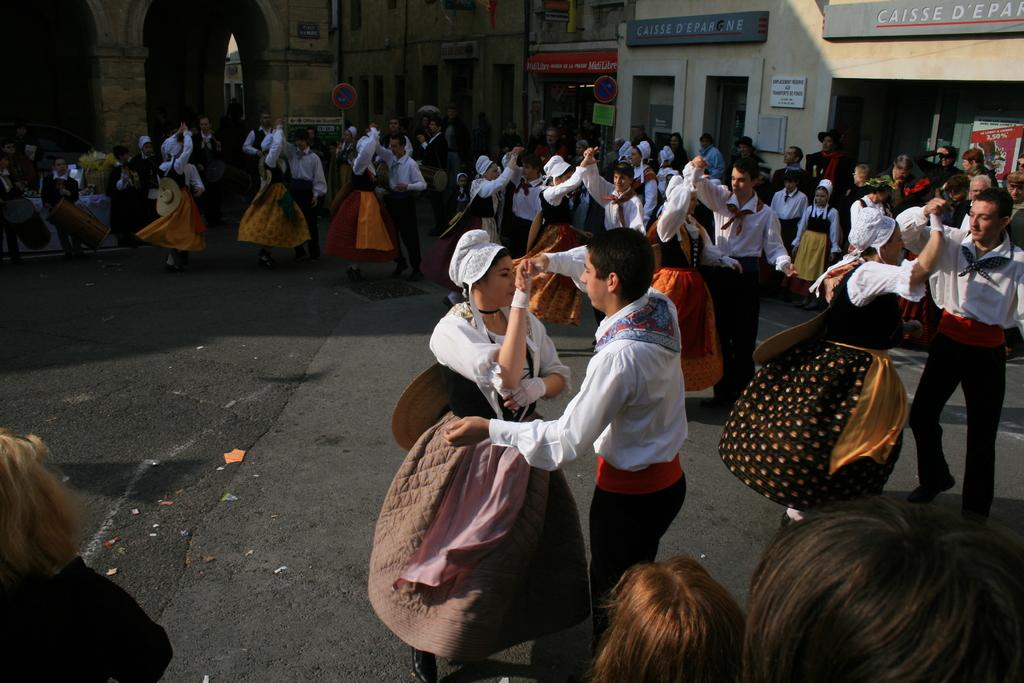What is happening in the image involving the group of people? Some people are dancing on the road in the image. What can be seen at the top of the image? Houses, walls, sign boards, hoardings, and banners are visible at the top of the image. How many different types of structures or objects are present at the top of the image? There are five different types of structures or objects present at the top of the image: houses, walls, sign boards, hoardings, and banners. What type of quiet poison is being used in the design of the banners in the image? There is no mention of poison or design in the image, and the banners do not appear to be related to any type of poison. 